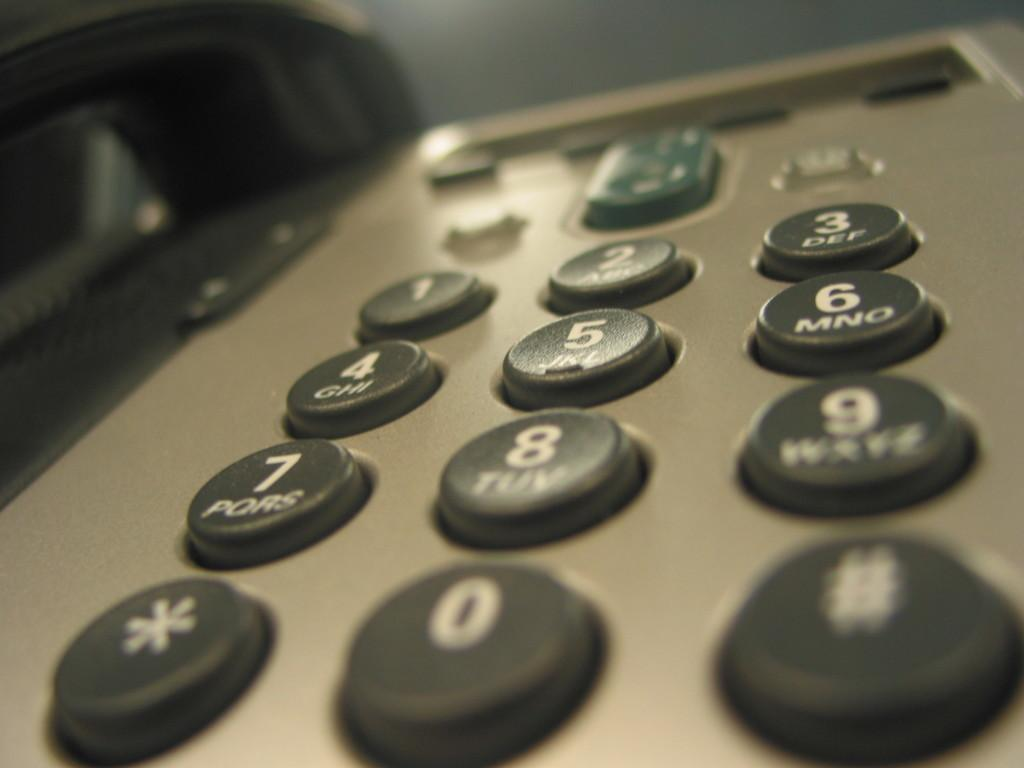<image>
Write a terse but informative summary of the picture. the numbers 1 to 0 that are on some kind of phone 